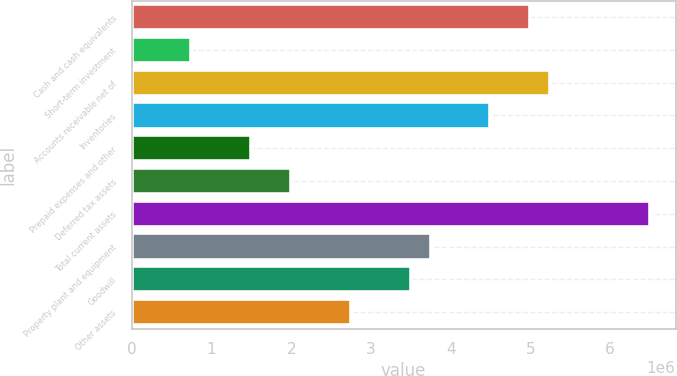Convert chart to OTSL. <chart><loc_0><loc_0><loc_500><loc_500><bar_chart><fcel>Cash and cash equivalents<fcel>Short-term investment<fcel>Accounts receivable net of<fcel>Inventories<fcel>Prepaid expenses and other<fcel>Deferred tax assets<fcel>Total current assets<fcel>Property plant and equipment<fcel>Goodwill<fcel>Other assets<nl><fcel>4.99752e+06<fcel>749631<fcel>5.24739e+06<fcel>4.49777e+06<fcel>1.49926e+06<fcel>1.99901e+06<fcel>6.49677e+06<fcel>3.74814e+06<fcel>3.49826e+06<fcel>2.74864e+06<nl></chart> 